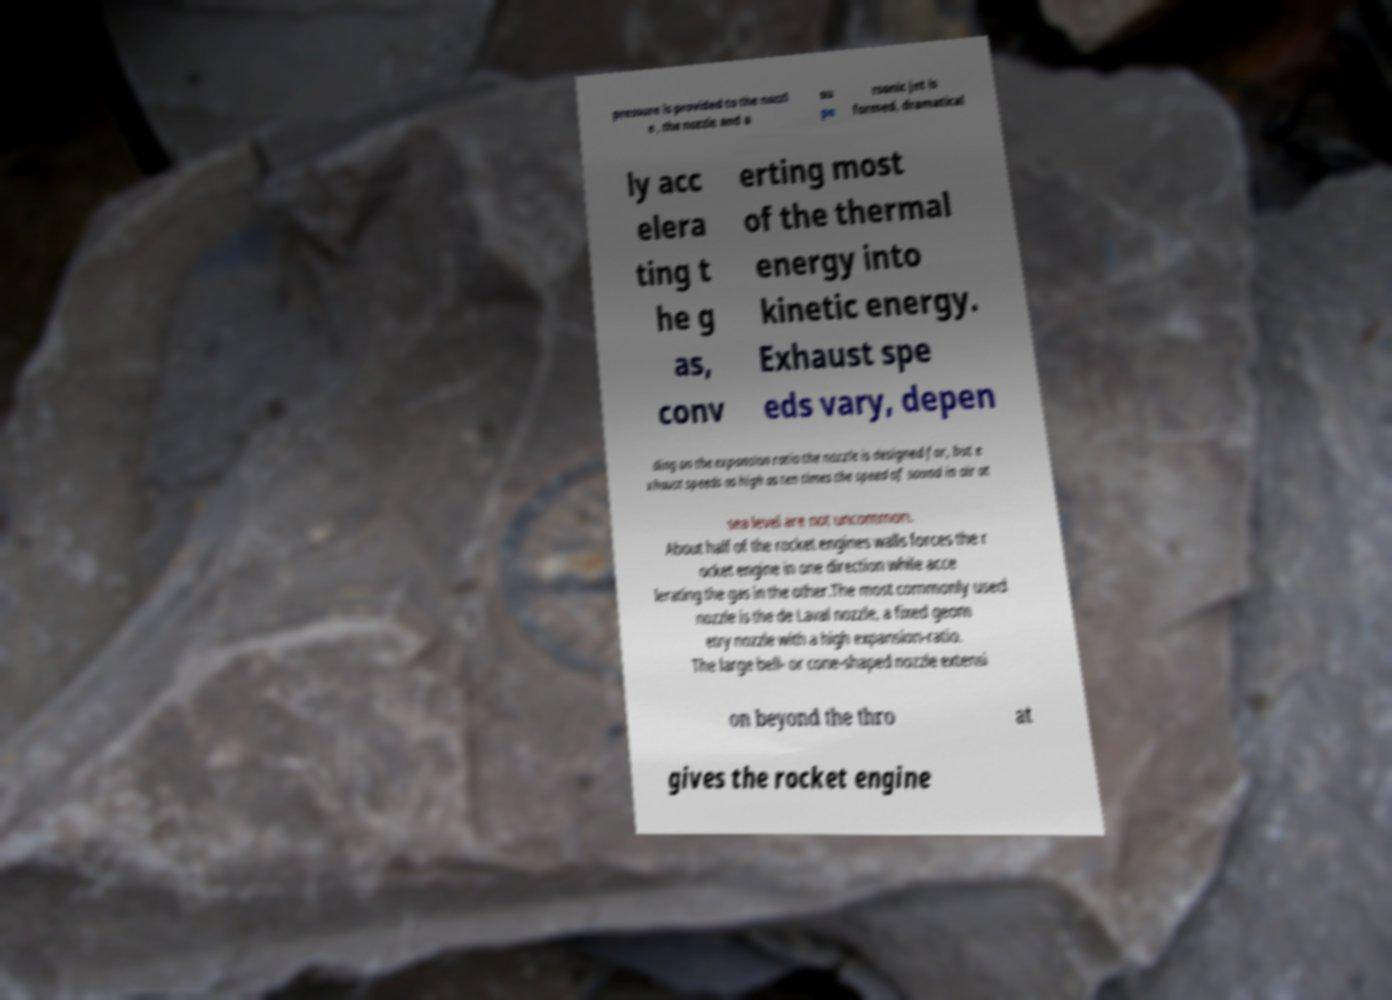Could you extract and type out the text from this image? pressure is provided to the nozzl e , the nozzle and a su pe rsonic jet is formed, dramatical ly acc elera ting t he g as, conv erting most of the thermal energy into kinetic energy. Exhaust spe eds vary, depen ding on the expansion ratio the nozzle is designed for, but e xhaust speeds as high as ten times the speed of sound in air at sea level are not uncommon. About half of the rocket engines walls forces the r ocket engine in one direction while acce lerating the gas in the other.The most commonly used nozzle is the de Laval nozzle, a fixed geom etry nozzle with a high expansion-ratio. The large bell- or cone-shaped nozzle extensi on beyond the thro at gives the rocket engine 